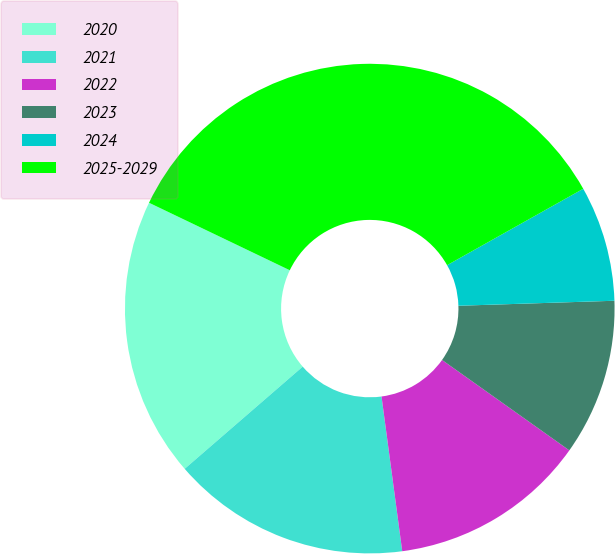<chart> <loc_0><loc_0><loc_500><loc_500><pie_chart><fcel>2020<fcel>2021<fcel>2022<fcel>2023<fcel>2024<fcel>2025-2029<nl><fcel>18.47%<fcel>15.76%<fcel>13.05%<fcel>10.34%<fcel>7.63%<fcel>34.74%<nl></chart> 